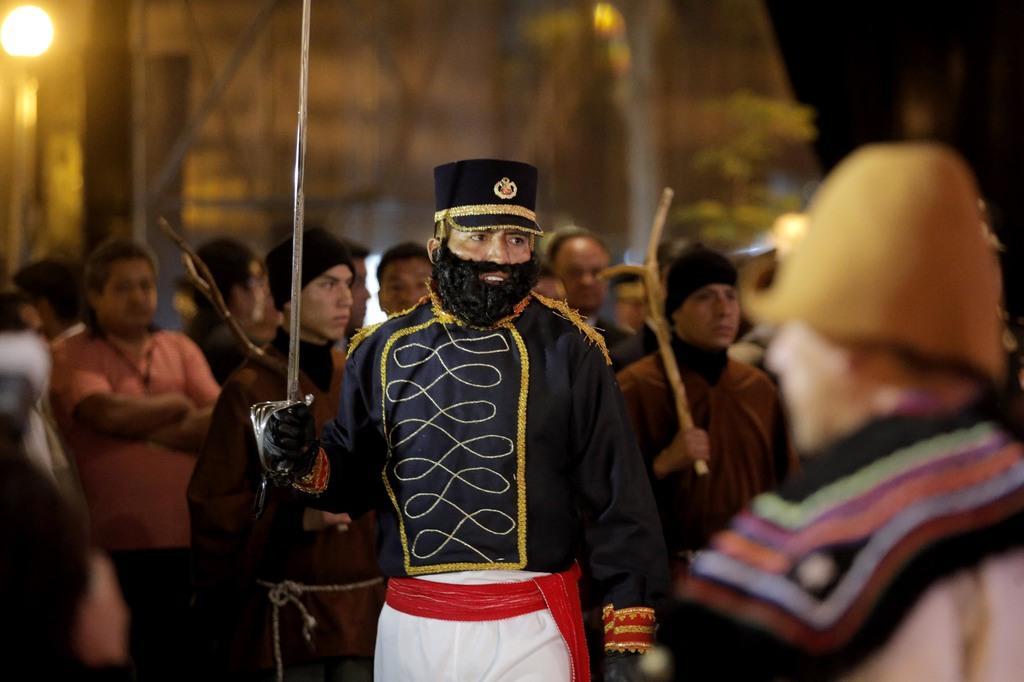In one or two sentences, can you explain what this image depicts? In this image there is a person wearing a cap is holding a sword in his hand. Behind him there are few persons standing. Right side there is a person wearing a cap. Left side there is a street light. Background is blurry. 